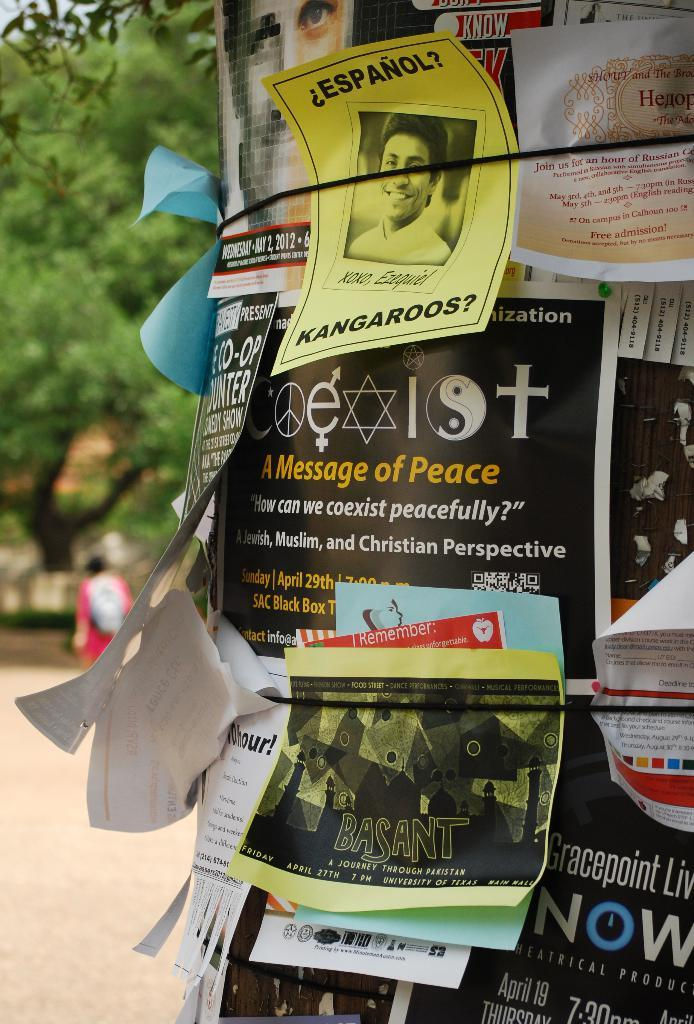<image>
Give a short and clear explanation of the subsequent image. flyers on a pole with one that says 'espanol kangaroos?' on it 